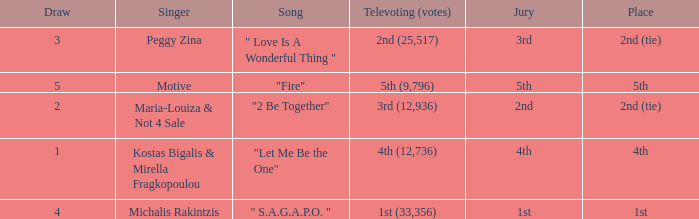What is the greatest draw that has 4th for place? 1.0. Could you parse the entire table? {'header': ['Draw', 'Singer', 'Song', 'Televoting (votes)', 'Jury', 'Place'], 'rows': [['3', 'Peggy Zina', '" Love Is A Wonderful Thing "', '2nd (25,517)', '3rd', '2nd (tie)'], ['5', 'Motive', '"Fire"', '5th (9,796)', '5th', '5th'], ['2', 'Maria-Louiza & Not 4 Sale', '"2 Be Together"', '3rd (12,936)', '2nd', '2nd (tie)'], ['1', 'Kostas Bigalis & Mirella Fragkopoulou', '"Let Me Be the One"', '4th (12,736)', '4th', '4th'], ['4', 'Michalis Rakintzis', '" S.A.G.A.P.O. "', '1st (33,356)', '1st', '1st']]} 